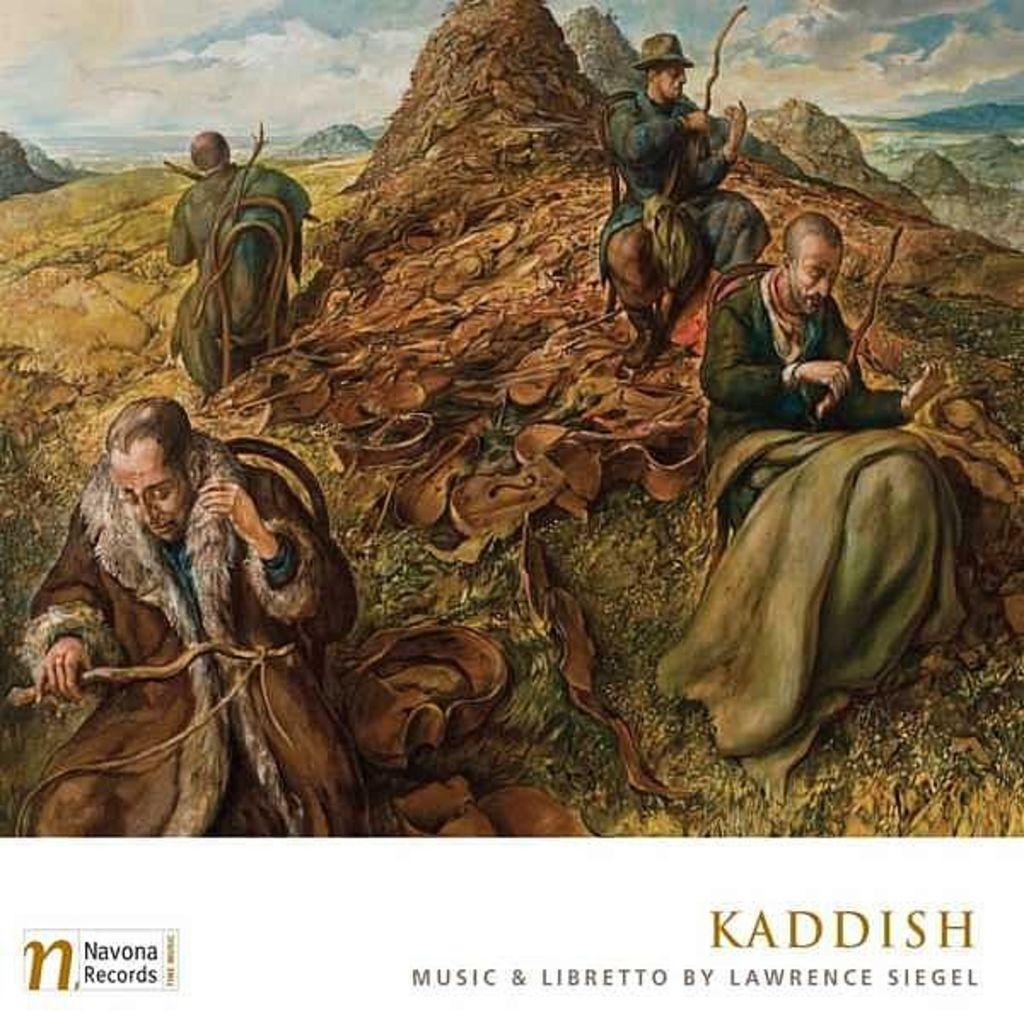Could you give a brief overview of what you see in this image? This is an edited image. Here we can see four persons, rocks, and few objects. In the background there is sky with clouds. At the bottom of the image we can see something is written on it. 